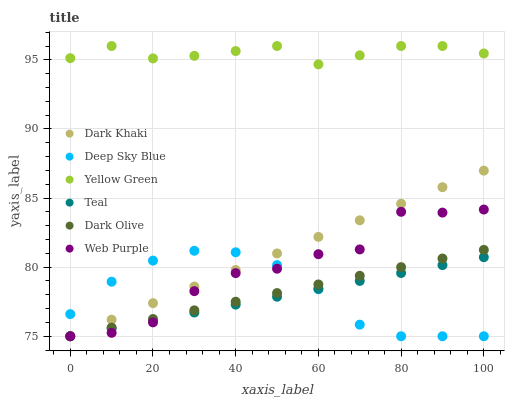Does Teal have the minimum area under the curve?
Answer yes or no. Yes. Does Yellow Green have the maximum area under the curve?
Answer yes or no. Yes. Does Dark Olive have the minimum area under the curve?
Answer yes or no. No. Does Dark Olive have the maximum area under the curve?
Answer yes or no. No. Is Dark Khaki the smoothest?
Answer yes or no. Yes. Is Web Purple the roughest?
Answer yes or no. Yes. Is Dark Olive the smoothest?
Answer yes or no. No. Is Dark Olive the roughest?
Answer yes or no. No. Does Dark Olive have the lowest value?
Answer yes or no. Yes. Does Yellow Green have the highest value?
Answer yes or no. Yes. Does Dark Olive have the highest value?
Answer yes or no. No. Is Web Purple less than Yellow Green?
Answer yes or no. Yes. Is Yellow Green greater than Deep Sky Blue?
Answer yes or no. Yes. Does Deep Sky Blue intersect Web Purple?
Answer yes or no. Yes. Is Deep Sky Blue less than Web Purple?
Answer yes or no. No. Is Deep Sky Blue greater than Web Purple?
Answer yes or no. No. Does Web Purple intersect Yellow Green?
Answer yes or no. No. 